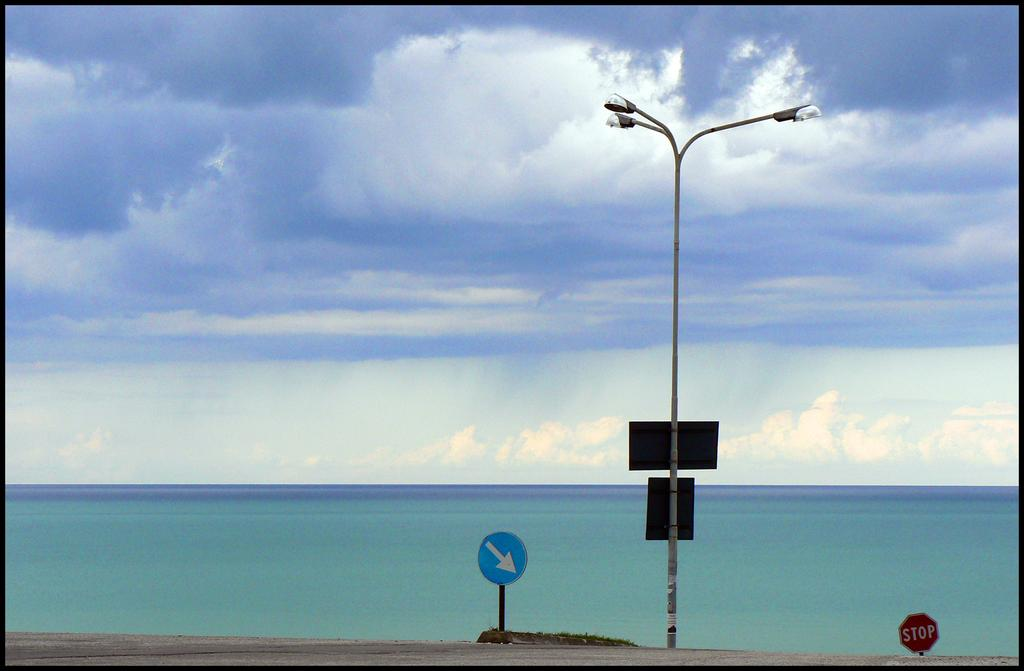What is the main object in the image? There is a street light in the image. Are there any other objects near the street light? Yes, there are two sign boards on either side of the street light. What can be seen in the background of the image? Water is visible in the background of the image. How would you describe the weather in the image? The sky is cloudy in the image. What type of badge is being worn by the person standing next to the street light? There is no person visible in the image, so it is not possible to determine if anyone is wearing a badge. On which side of the street light is the industry located? There is no industry present in the image; it only features a street light and sign boards. 